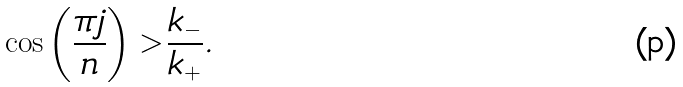<formula> <loc_0><loc_0><loc_500><loc_500>\cos \left ( \frac { \pi j } { n } \right ) > \frac { k _ { - } } { k _ { + } } .</formula> 